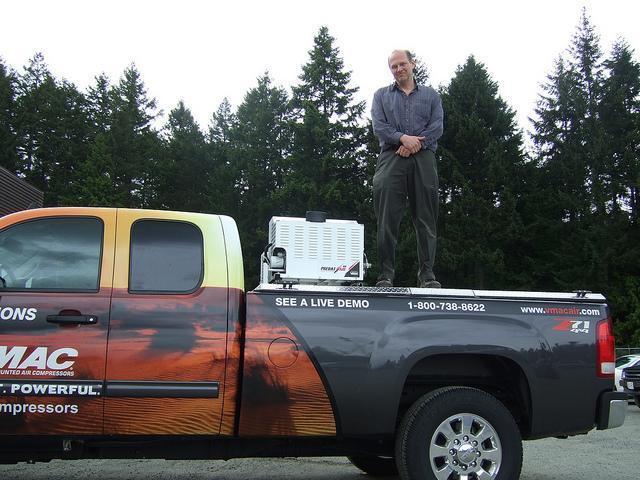How many trucks are in the picture?
Give a very brief answer. 1. 